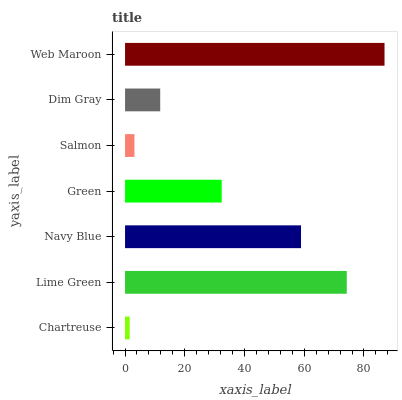Is Chartreuse the minimum?
Answer yes or no. Yes. Is Web Maroon the maximum?
Answer yes or no. Yes. Is Lime Green the minimum?
Answer yes or no. No. Is Lime Green the maximum?
Answer yes or no. No. Is Lime Green greater than Chartreuse?
Answer yes or no. Yes. Is Chartreuse less than Lime Green?
Answer yes or no. Yes. Is Chartreuse greater than Lime Green?
Answer yes or no. No. Is Lime Green less than Chartreuse?
Answer yes or no. No. Is Green the high median?
Answer yes or no. Yes. Is Green the low median?
Answer yes or no. Yes. Is Web Maroon the high median?
Answer yes or no. No. Is Navy Blue the low median?
Answer yes or no. No. 